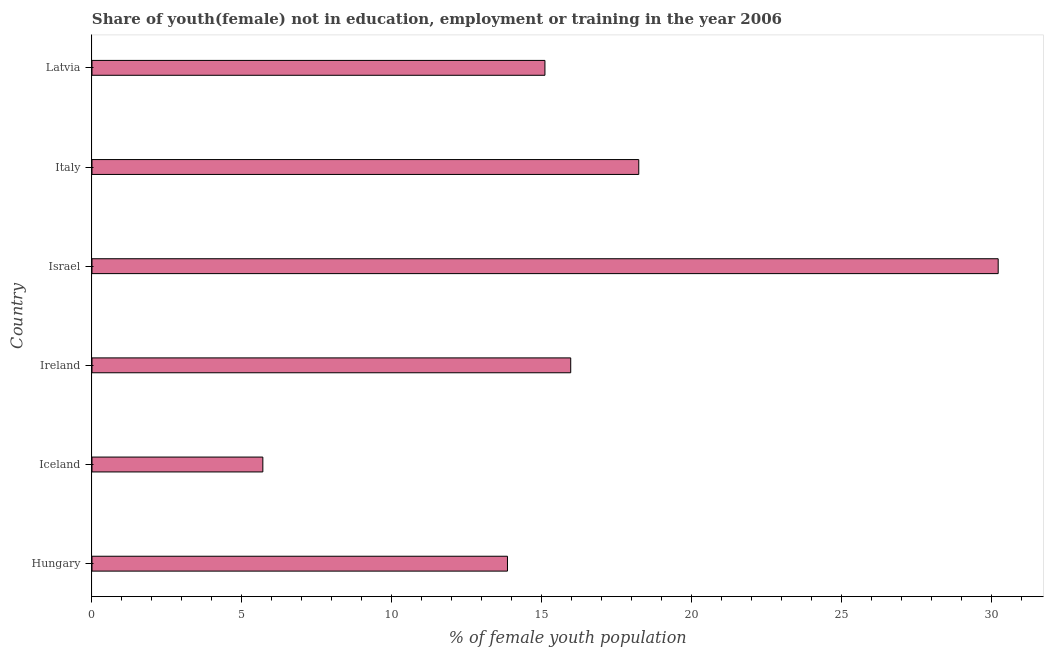Does the graph contain grids?
Ensure brevity in your answer.  No. What is the title of the graph?
Keep it short and to the point. Share of youth(female) not in education, employment or training in the year 2006. What is the label or title of the X-axis?
Provide a succinct answer. % of female youth population. What is the label or title of the Y-axis?
Offer a very short reply. Country. What is the unemployed female youth population in Latvia?
Your answer should be compact. 15.11. Across all countries, what is the maximum unemployed female youth population?
Provide a short and direct response. 30.23. Across all countries, what is the minimum unemployed female youth population?
Provide a succinct answer. 5.7. In which country was the unemployed female youth population minimum?
Give a very brief answer. Iceland. What is the sum of the unemployed female youth population?
Your answer should be very brief. 99.11. What is the difference between the unemployed female youth population in Hungary and Ireland?
Make the answer very short. -2.11. What is the average unemployed female youth population per country?
Give a very brief answer. 16.52. What is the median unemployed female youth population?
Your response must be concise. 15.54. In how many countries, is the unemployed female youth population greater than 28 %?
Give a very brief answer. 1. What is the ratio of the unemployed female youth population in Italy to that in Latvia?
Your answer should be very brief. 1.21. Is the unemployed female youth population in Hungary less than that in Israel?
Offer a terse response. Yes. Is the difference between the unemployed female youth population in Hungary and Ireland greater than the difference between any two countries?
Offer a very short reply. No. What is the difference between the highest and the second highest unemployed female youth population?
Your response must be concise. 11.99. What is the difference between the highest and the lowest unemployed female youth population?
Your answer should be very brief. 24.53. In how many countries, is the unemployed female youth population greater than the average unemployed female youth population taken over all countries?
Give a very brief answer. 2. How many bars are there?
Provide a succinct answer. 6. How many countries are there in the graph?
Keep it short and to the point. 6. Are the values on the major ticks of X-axis written in scientific E-notation?
Offer a terse response. No. What is the % of female youth population in Hungary?
Your answer should be very brief. 13.86. What is the % of female youth population in Iceland?
Make the answer very short. 5.7. What is the % of female youth population of Ireland?
Ensure brevity in your answer.  15.97. What is the % of female youth population of Israel?
Your answer should be very brief. 30.23. What is the % of female youth population in Italy?
Ensure brevity in your answer.  18.24. What is the % of female youth population in Latvia?
Your response must be concise. 15.11. What is the difference between the % of female youth population in Hungary and Iceland?
Keep it short and to the point. 8.16. What is the difference between the % of female youth population in Hungary and Ireland?
Offer a terse response. -2.11. What is the difference between the % of female youth population in Hungary and Israel?
Keep it short and to the point. -16.37. What is the difference between the % of female youth population in Hungary and Italy?
Make the answer very short. -4.38. What is the difference between the % of female youth population in Hungary and Latvia?
Make the answer very short. -1.25. What is the difference between the % of female youth population in Iceland and Ireland?
Ensure brevity in your answer.  -10.27. What is the difference between the % of female youth population in Iceland and Israel?
Your answer should be very brief. -24.53. What is the difference between the % of female youth population in Iceland and Italy?
Provide a succinct answer. -12.54. What is the difference between the % of female youth population in Iceland and Latvia?
Provide a succinct answer. -9.41. What is the difference between the % of female youth population in Ireland and Israel?
Provide a succinct answer. -14.26. What is the difference between the % of female youth population in Ireland and Italy?
Your answer should be very brief. -2.27. What is the difference between the % of female youth population in Ireland and Latvia?
Your response must be concise. 0.86. What is the difference between the % of female youth population in Israel and Italy?
Keep it short and to the point. 11.99. What is the difference between the % of female youth population in Israel and Latvia?
Provide a short and direct response. 15.12. What is the difference between the % of female youth population in Italy and Latvia?
Offer a very short reply. 3.13. What is the ratio of the % of female youth population in Hungary to that in Iceland?
Your answer should be compact. 2.43. What is the ratio of the % of female youth population in Hungary to that in Ireland?
Your response must be concise. 0.87. What is the ratio of the % of female youth population in Hungary to that in Israel?
Your answer should be very brief. 0.46. What is the ratio of the % of female youth population in Hungary to that in Italy?
Your answer should be very brief. 0.76. What is the ratio of the % of female youth population in Hungary to that in Latvia?
Provide a succinct answer. 0.92. What is the ratio of the % of female youth population in Iceland to that in Ireland?
Ensure brevity in your answer.  0.36. What is the ratio of the % of female youth population in Iceland to that in Israel?
Offer a terse response. 0.19. What is the ratio of the % of female youth population in Iceland to that in Italy?
Ensure brevity in your answer.  0.31. What is the ratio of the % of female youth population in Iceland to that in Latvia?
Provide a succinct answer. 0.38. What is the ratio of the % of female youth population in Ireland to that in Israel?
Ensure brevity in your answer.  0.53. What is the ratio of the % of female youth population in Ireland to that in Italy?
Provide a short and direct response. 0.88. What is the ratio of the % of female youth population in Ireland to that in Latvia?
Your answer should be very brief. 1.06. What is the ratio of the % of female youth population in Israel to that in Italy?
Give a very brief answer. 1.66. What is the ratio of the % of female youth population in Israel to that in Latvia?
Give a very brief answer. 2. What is the ratio of the % of female youth population in Italy to that in Latvia?
Keep it short and to the point. 1.21. 